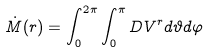Convert formula to latex. <formula><loc_0><loc_0><loc_500><loc_500>\dot { M } ( r ) = \int ^ { 2 \pi } _ { 0 } \int ^ { \pi } _ { 0 } D V ^ { r } d \vartheta d \varphi</formula> 